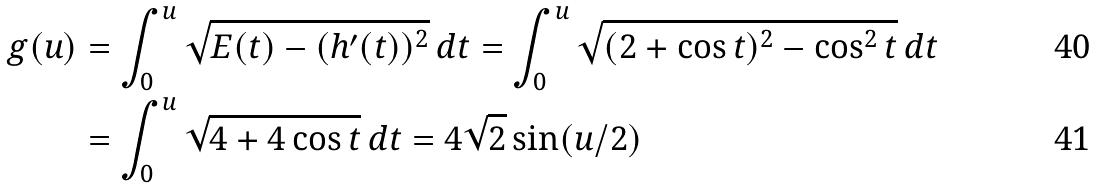Convert formula to latex. <formula><loc_0><loc_0><loc_500><loc_500>g ( u ) & = \int _ { 0 } ^ { u } \sqrt { E ( t ) - ( h ^ { \prime } ( t ) ) ^ { 2 } } \, d t = \int _ { 0 } ^ { u } \sqrt { ( 2 + \cos t ) ^ { 2 } - \cos ^ { 2 } t } \, d t \\ & = \int _ { 0 } ^ { u } \sqrt { 4 + 4 \cos t } \, d t = 4 \sqrt { 2 } \sin ( u / 2 )</formula> 